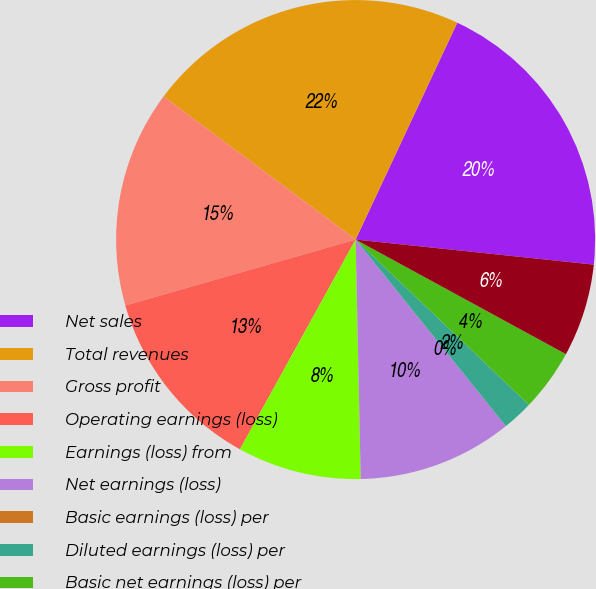Convert chart to OTSL. <chart><loc_0><loc_0><loc_500><loc_500><pie_chart><fcel>Net sales<fcel>Total revenues<fcel>Gross profit<fcel>Operating earnings (loss)<fcel>Earnings (loss) from<fcel>Net earnings (loss)<fcel>Basic earnings (loss) per<fcel>Diluted earnings (loss) per<fcel>Basic net earnings (loss) per<fcel>Diluted net earnings (loss)<nl><fcel>19.69%<fcel>21.78%<fcel>14.63%<fcel>12.54%<fcel>8.36%<fcel>10.45%<fcel>0.0%<fcel>2.09%<fcel>4.18%<fcel>6.27%<nl></chart> 